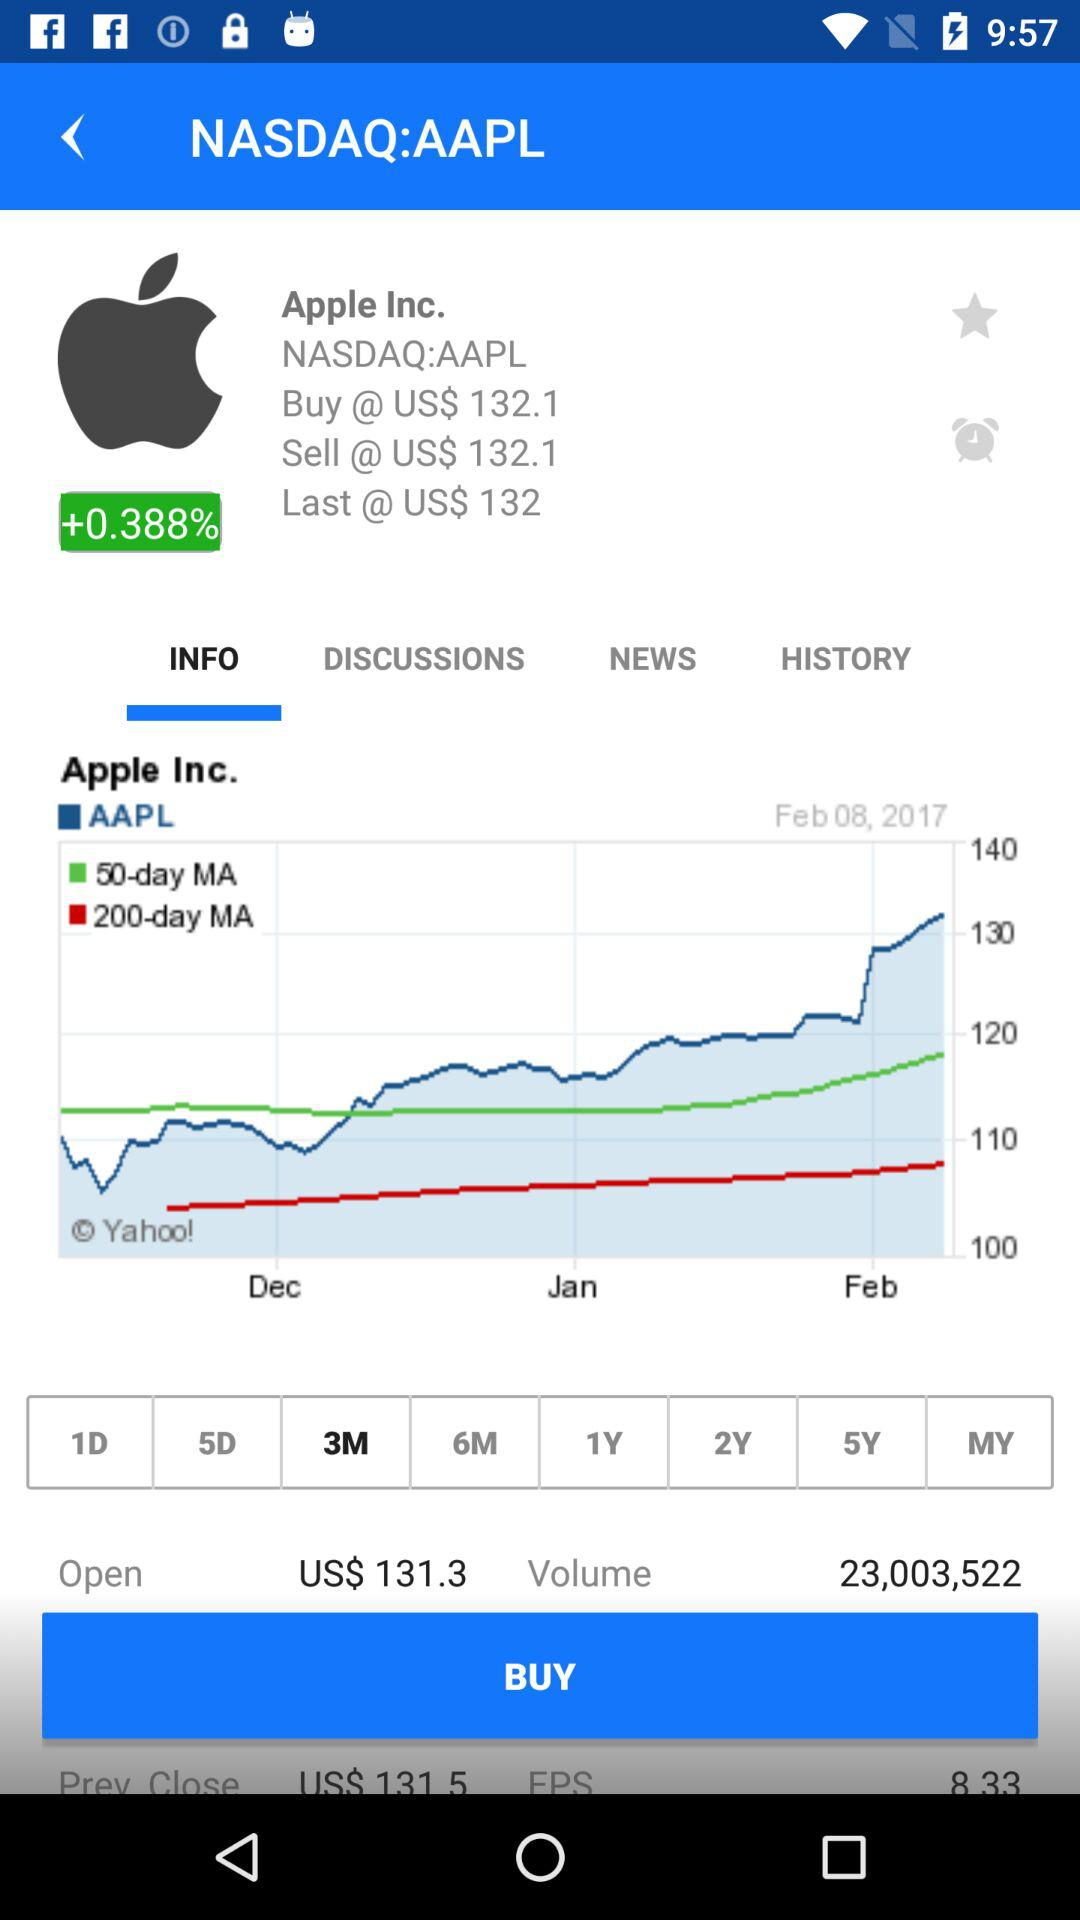What is the buy value? The buy value is US$ 132.1. 